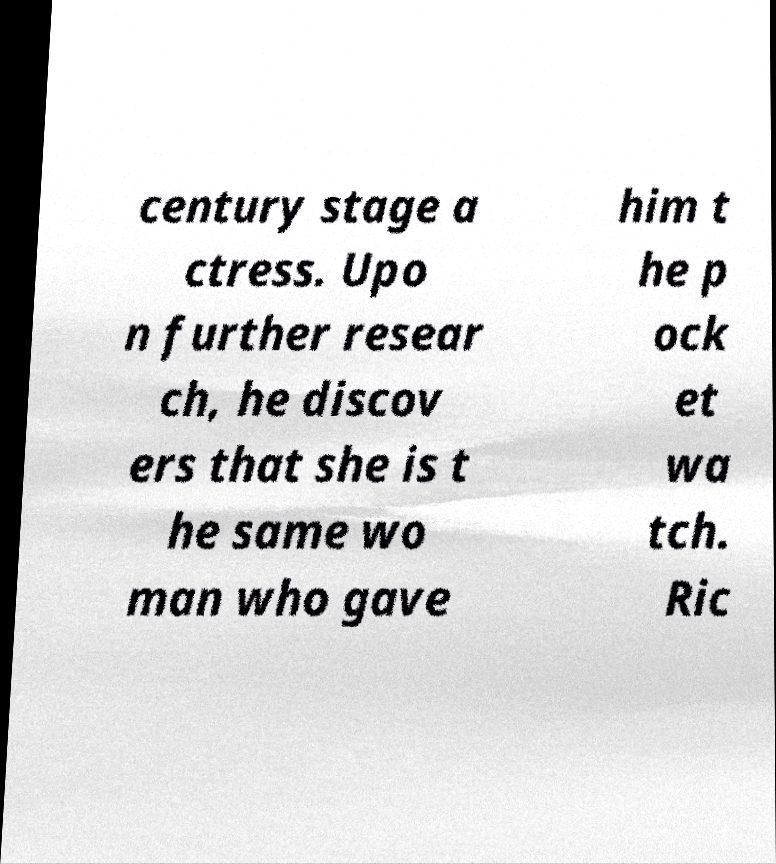There's text embedded in this image that I need extracted. Can you transcribe it verbatim? century stage a ctress. Upo n further resear ch, he discov ers that she is t he same wo man who gave him t he p ock et wa tch. Ric 